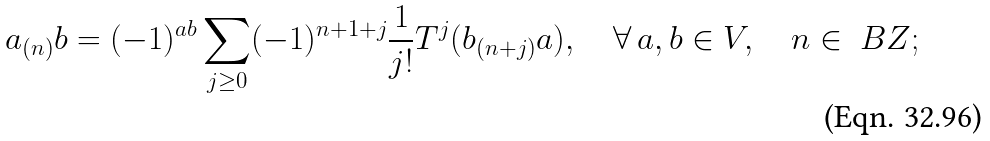<formula> <loc_0><loc_0><loc_500><loc_500>a _ { ( n ) } b = ( - 1 ) ^ { a b } \sum _ { j \geq 0 } ( - 1 ) ^ { n + 1 + j } \frac { 1 } { j ! } T ^ { j } ( b _ { ( n + j ) } a ) , \quad \forall \, a , b \in V , \quad n \in \ B Z ;</formula> 